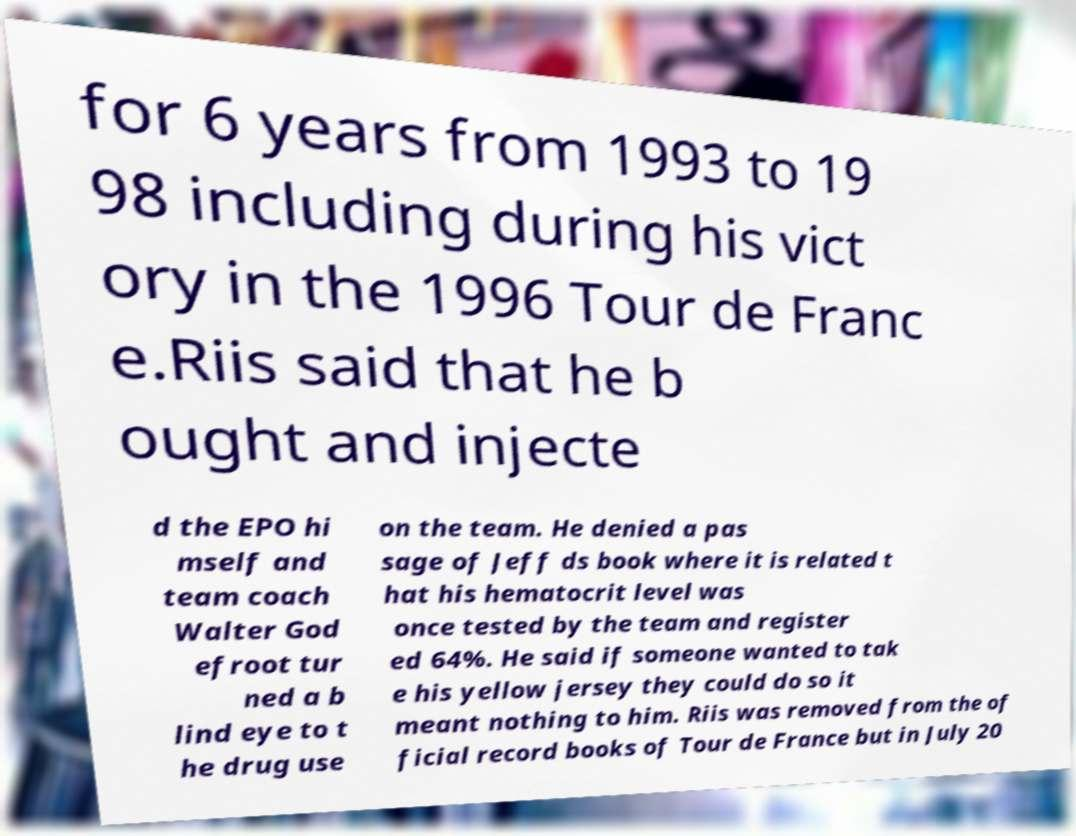There's text embedded in this image that I need extracted. Can you transcribe it verbatim? for 6 years from 1993 to 19 98 including during his vict ory in the 1996 Tour de Franc e.Riis said that he b ought and injecte d the EPO hi mself and team coach Walter God efroot tur ned a b lind eye to t he drug use on the team. He denied a pas sage of Jeff ds book where it is related t hat his hematocrit level was once tested by the team and register ed 64%. He said if someone wanted to tak e his yellow jersey they could do so it meant nothing to him. Riis was removed from the of ficial record books of Tour de France but in July 20 